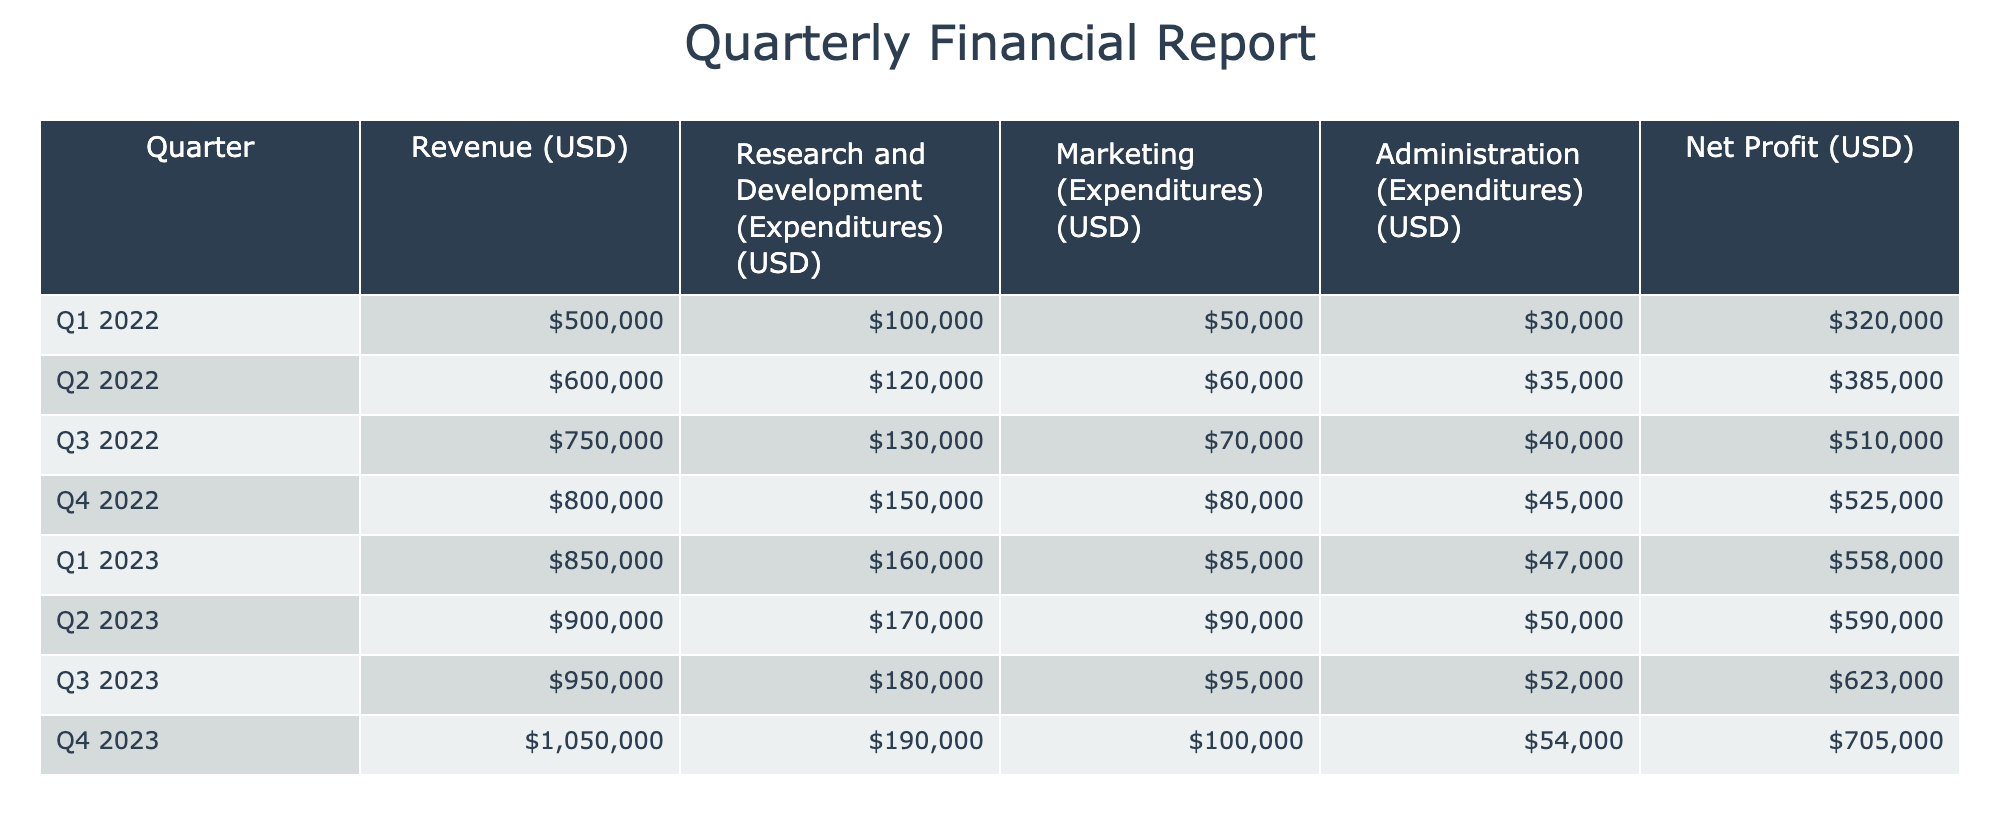What was the revenue in Q3 2023? Looking at the table, the revenue for Q3 2023 is listed directly under the Revenue (USD) column for the corresponding quarter. The value is $950,000.
Answer: $950,000 What was the total expenditure on Research and Development from Q1 2022 to Q4 2023? To find the total expenditure on Research and Development, sum the values in that column: 100,000 + 120,000 + 130,000 + 150,000 + 160,000 + 170,000 + 180,000 + 190,000 = 1,100,000.
Answer: $1,100,000 Did the net profit increase from Q2 2023 to Q3 2023? A comparison of net profit values shows that it was $590,000 in Q2 2023 and $623,000 in Q3 2023, indicating an increase.
Answer: Yes What is the average Revenue over all quarters? First, sum the revenue values: (500,000 + 600,000 + 750,000 + 800,000 + 850,000 + 900,000 + 950,000 + 1,050,000) = 5,400,000. There are 8 quarters, so the average is 5,400,000 / 8 = 675,000.
Answer: $675,000 Which quarter had the highest net profit, and what was the amount? Checking the net profit column, the highest value appears in Q4 2023, which reports a net profit of $705,000.
Answer: Q4 2023, $705,000 What is the difference in Marketing expenditures between Q1 2022 and Q4 2023? The Marketing expenditures for Q1 2022 are $50,000 and for Q4 2023 are $100,000. The difference is calculated as $100,000 - $50,000 = $50,000.
Answer: $50,000 Was total expenditure on Administration greater than $200,000 in any quarter? By examining the Administration expenditures for each quarter, none exceed $200,000; the maximum recorded is $54,000 in Q4 2023.
Answer: No How much was spent on total expenditures in Q2 2023? In Q2 2023, the expenditures are as follows: R&D: $170,000, Marketing: $90,000, and Administration: $50,000. Adding these together: 170,000 + 90,000 + 50,000 = 310,000.
Answer: $310,000 What is the percentage increase in Revenue from Q1 2022 to Q4 2023? The Revenue in Q1 2022 is $500,000 and in Q4 2023 is $1,050,000. The increase is ($1,050,000 - $500,000) / $500,000 * 100%, which simplifies to 110%.
Answer: 110% 